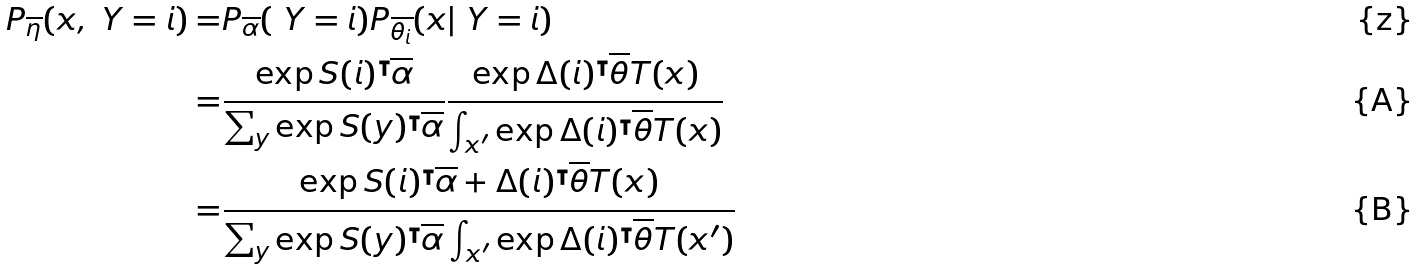Convert formula to latex. <formula><loc_0><loc_0><loc_500><loc_500>P _ { \overline { \eta } } ( x , \ Y = i ) = & P _ { \overline { \alpha } } ( \ Y = i ) P _ { \overline { \theta _ { i } } } ( x | \ Y = i ) \\ = & \frac { \exp { S ( i ) ^ { \intercal } \overline { \alpha } } } { \sum _ { y } \exp { S ( y ) ^ { \intercal } \overline { \alpha } } } \frac { \exp { \Delta ( i ) ^ { \intercal } \overline { \theta } T ( x ) } } { \int _ { x ^ { \prime } } \exp { \Delta ( i ) ^ { \intercal } \overline { \theta } T ( x ) } } \\ = & \frac { \exp { S ( i ) ^ { \intercal } \overline { \alpha } + \Delta ( i ) ^ { \intercal } \overline { \theta } T ( x ) } } { \sum _ { y } \exp { S ( y ) ^ { \intercal } \overline { \alpha } } \int _ { x ^ { \prime } } \exp { \Delta ( i ) ^ { \intercal } \overline { \theta } T ( x ^ { \prime } ) } }</formula> 